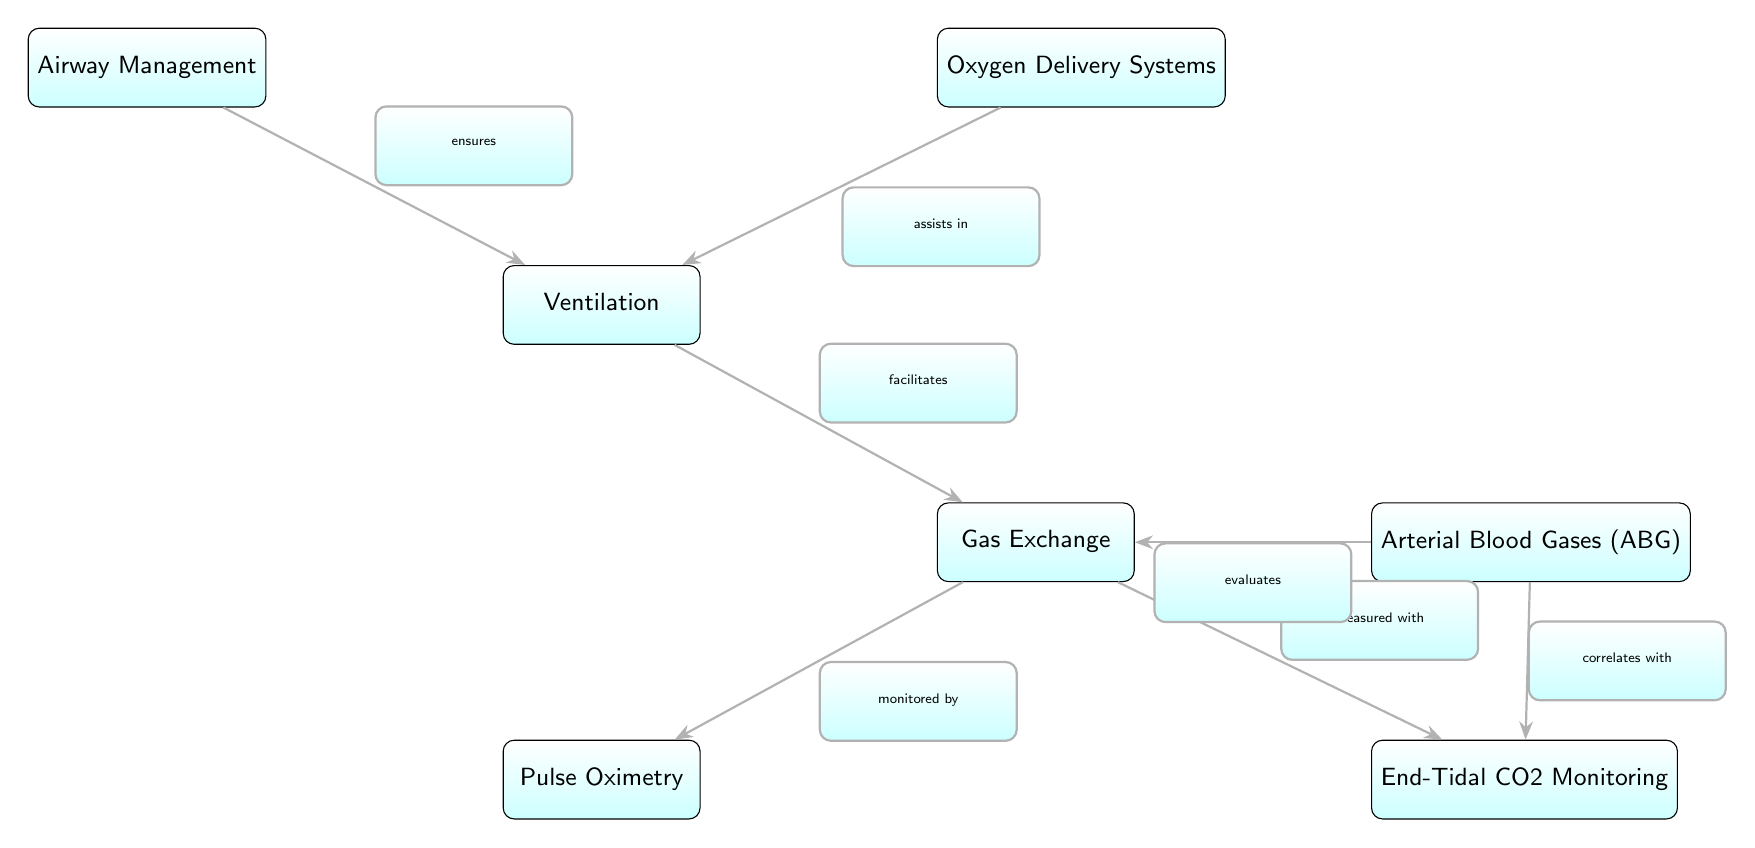What is the first node in the diagram? The first node listed in the diagram is "Airway Management," which is positioned at the top of the diagram.
Answer: Airway Management How many nodes are in the diagram? By counting all distinct squares in the diagram, there are a total of seven nodes presented.
Answer: 7 What does "Ventilation" facilitate? According to the diagram, "Ventilation" facilitates "Gas Exchange," which is indicated by the directed edge connecting these two nodes.
Answer: Gas Exchange What is monitored by "Gas Exchange"? The diagram indicates that "Gas Exchange" is monitored by "Pulse Oximetry," as this relationship is explicitly shown by the connecting edge.
Answer: Pulse Oximetry What does "End-Tidal CO2 Monitoring" measure? "End-Tidal CO2 Monitoring" measures "Gas Exchange," highlighted in the diagram by the directed edge that leads from "Gas Exchange" to "End-Tidal CO2 Monitoring."
Answer: Gas Exchange What role does "Oxygen Delivery Systems" play in the diagram? "Oxygen Delivery Systems" assists in "Ventilation," as depicted by the edge connecting the two nodes, illustrating their relationship.
Answer: Assists in Ventilation How does "Arterial Blood Gases (ABG)" correlate with other processes in the diagram? "Arterial Blood Gases (ABG)" correlates with "End-Tidal CO2 Monitoring," and it also evaluates "Gas Exchange," shown through the edges connecting these nodes. This correlation suggests a relationship between gas exchange and end-tidal CO2 measurements.
Answer: Correlates with End-Tidal CO2 Monitoring Which nodes are directly connected to "Gas Exchange"? "Gas Exchange" is directly connected to three nodes: "Ventilation," "Pulse Oximetry," and "End-Tidal CO2 Monitoring," as indicated by the edges leading from "Gas Exchange" to these nodes.
Answer: Ventilation, Pulse Oximetry, End-Tidal CO2 Monitoring What is the connection type between "Airway Management" and "Ventilation"? The connection is described as "ensures," which denotes a supportive or guaranteeing relationship in the flow of processes illustrated in the diagram.
Answer: Ensures 